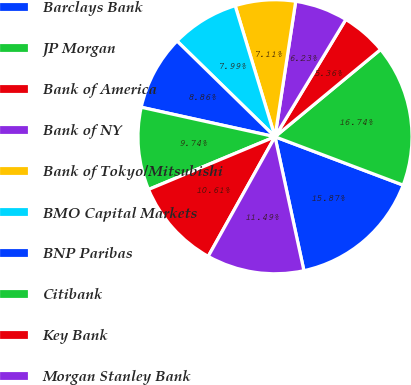Convert chart. <chart><loc_0><loc_0><loc_500><loc_500><pie_chart><fcel>Barclays Bank<fcel>JP Morgan<fcel>Bank of America<fcel>Bank of NY<fcel>Bank of Tokyo/Mitsubishi<fcel>BMO Capital Markets<fcel>BNP Paribas<fcel>Citibank<fcel>Key Bank<fcel>Morgan Stanley Bank<nl><fcel>15.87%<fcel>16.74%<fcel>5.36%<fcel>6.23%<fcel>7.11%<fcel>7.99%<fcel>8.86%<fcel>9.74%<fcel>10.61%<fcel>11.49%<nl></chart> 